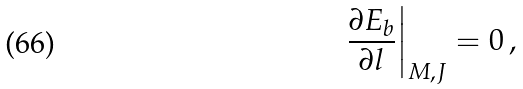Convert formula to latex. <formula><loc_0><loc_0><loc_500><loc_500>\left . \frac { \partial E _ { b } } { \partial l } \right | _ { M , J } = 0 \, ,</formula> 